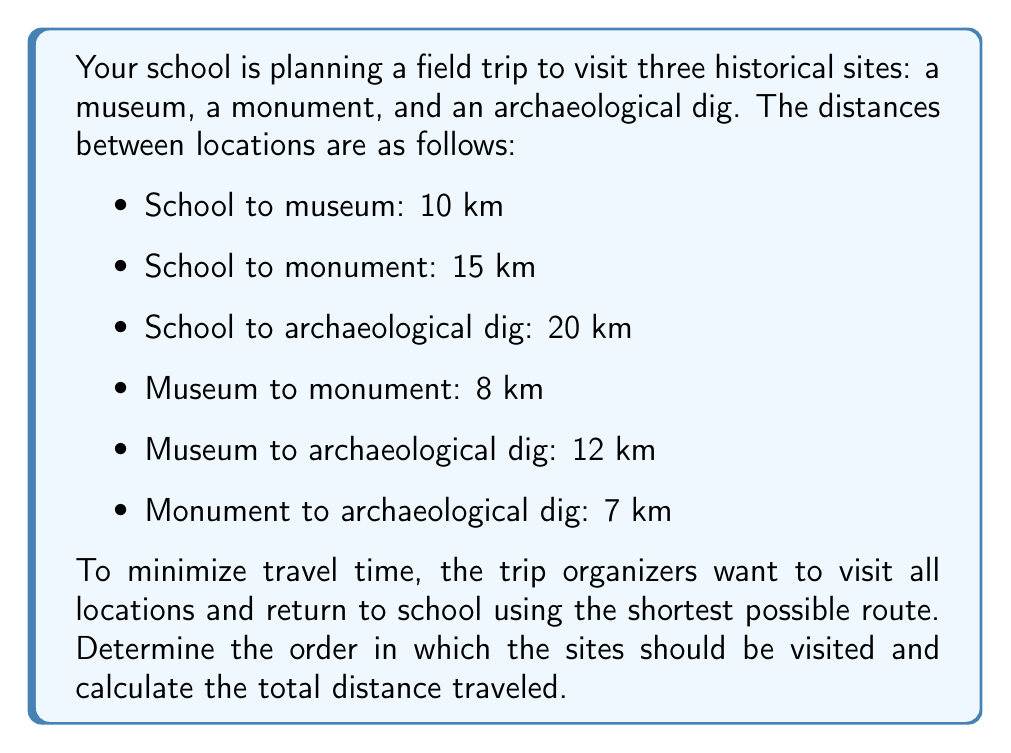Show me your answer to this math problem. To solve this problem, we need to consider all possible routes and calculate their total distances. There are six possible routes (3! = 6) since we have three locations to visit.

Let's denote:
S = School
M = Museum
N = Monument
A = Archaeological dig

Possible routes and their distances:

1. S → M → N → A → S
   $10 + 8 + 7 + 20 = 45$ km

2. S → M → A → N → S
   $10 + 12 + 7 + 15 = 44$ km

3. S → N → M → A → S
   $15 + 8 + 12 + 20 = 55$ km

4. S → N → A → M → S
   $15 + 7 + 12 + 10 = 44$ km

5. S → A → M → N → S
   $20 + 12 + 8 + 15 = 55$ km

6. S → A → N → M → S
   $20 + 7 + 8 + 10 = 45$ km

The shortest routes are options 2 and 4, both with a total distance of 44 km. Either of these routes would be the most efficient.

For the purpose of providing a single answer, we'll choose option 2:
School → Museum → Archaeological dig → Monument → School
Answer: The most efficient route is:
School → Museum → Archaeological dig → Monument → School

Total distance: 44 km 